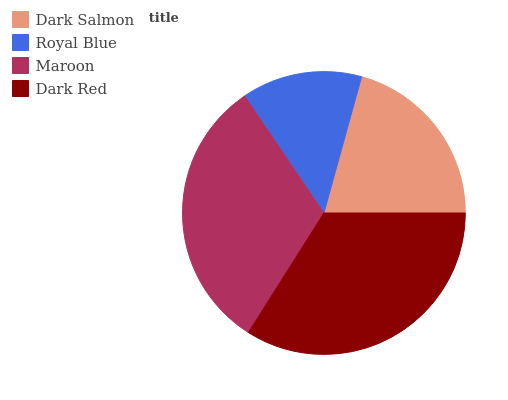Is Royal Blue the minimum?
Answer yes or no. Yes. Is Dark Red the maximum?
Answer yes or no. Yes. Is Maroon the minimum?
Answer yes or no. No. Is Maroon the maximum?
Answer yes or no. No. Is Maroon greater than Royal Blue?
Answer yes or no. Yes. Is Royal Blue less than Maroon?
Answer yes or no. Yes. Is Royal Blue greater than Maroon?
Answer yes or no. No. Is Maroon less than Royal Blue?
Answer yes or no. No. Is Maroon the high median?
Answer yes or no. Yes. Is Dark Salmon the low median?
Answer yes or no. Yes. Is Dark Red the high median?
Answer yes or no. No. Is Maroon the low median?
Answer yes or no. No. 